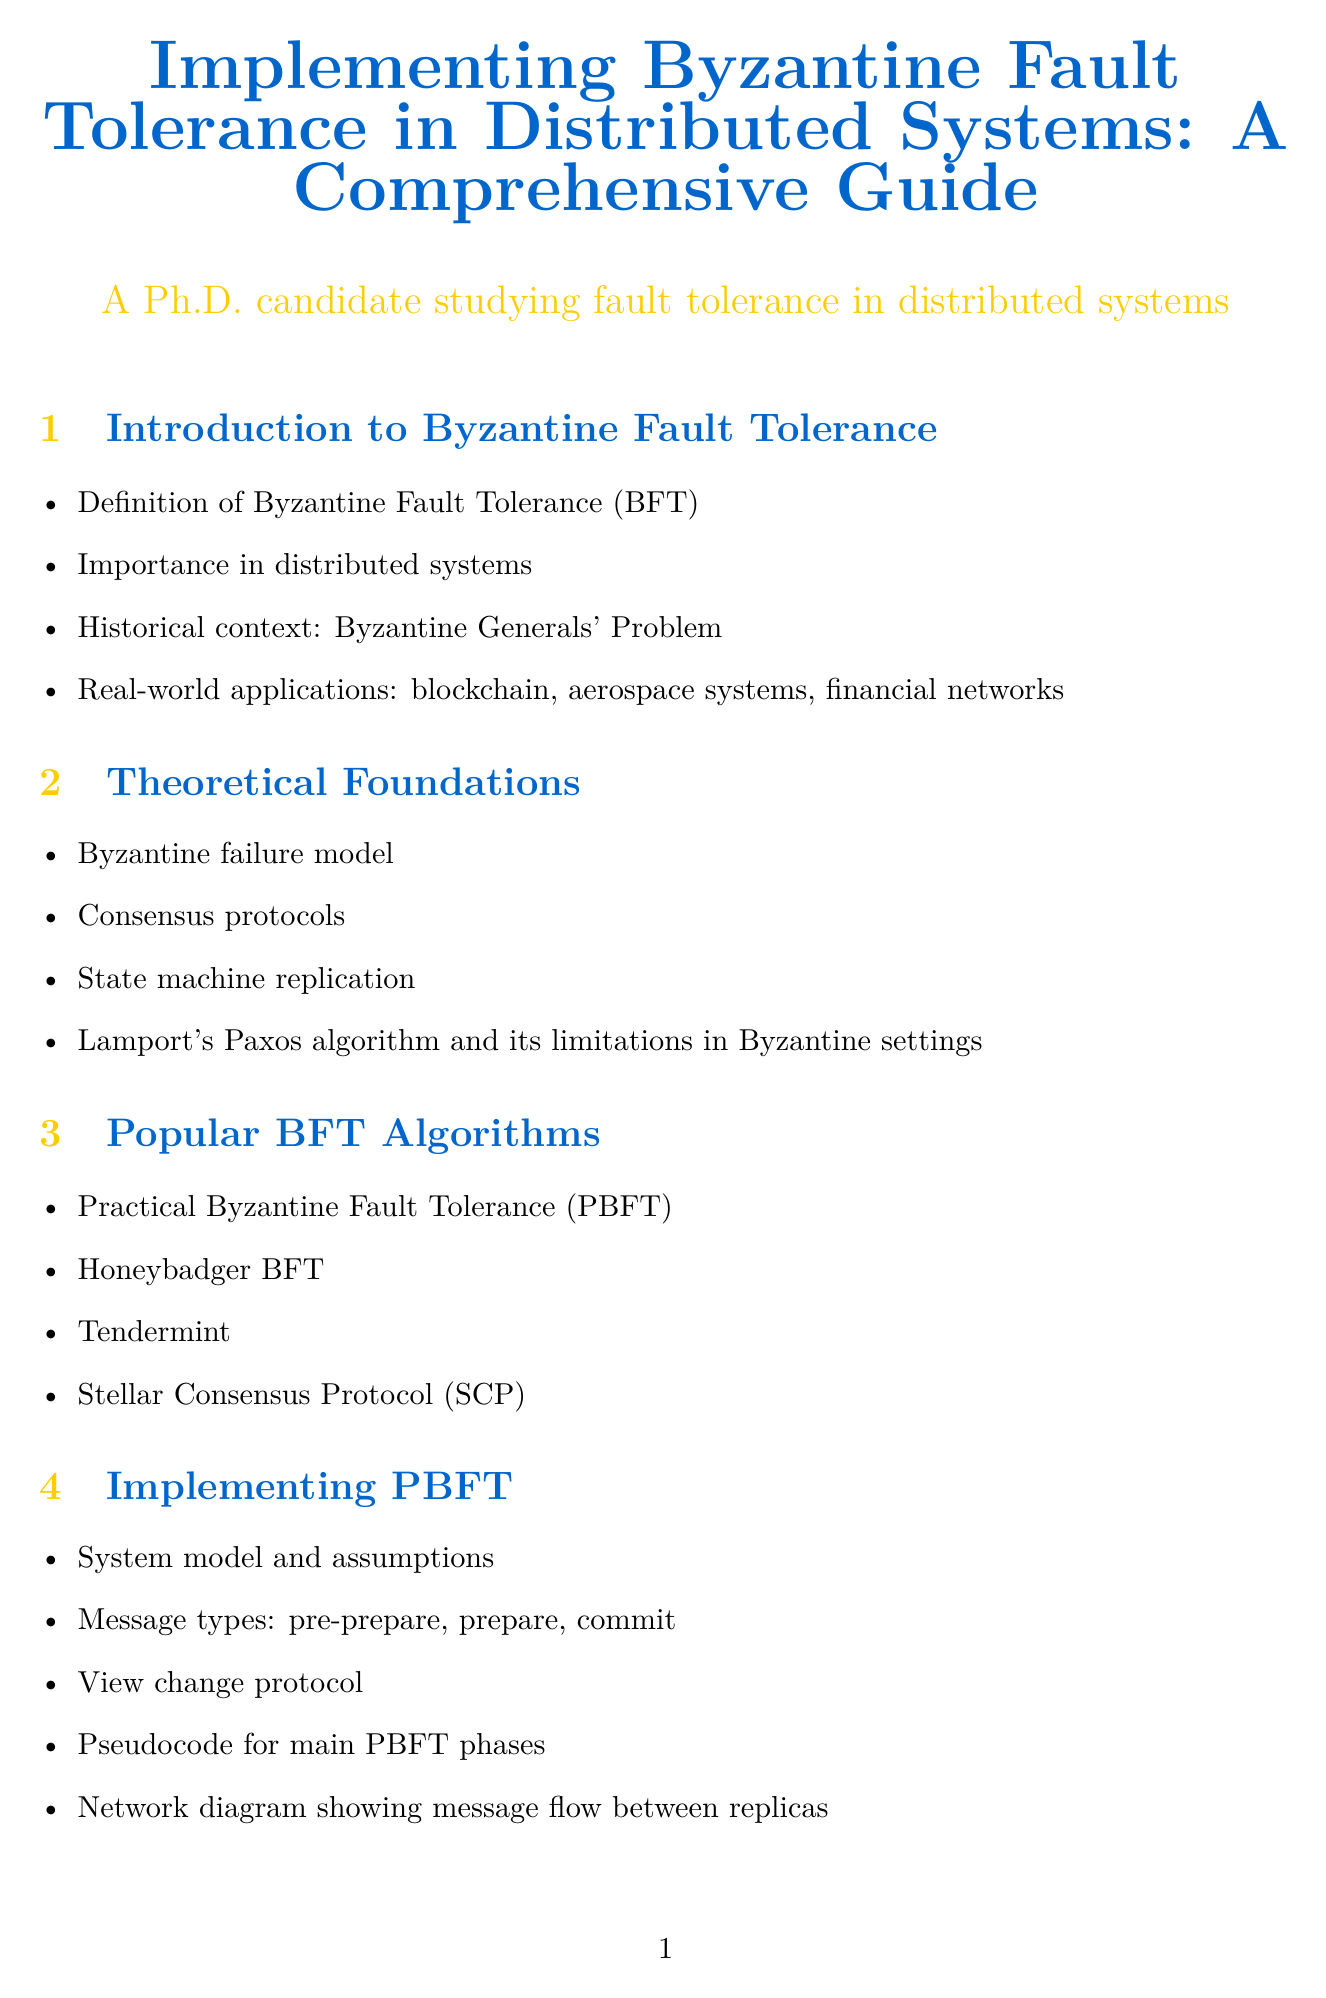What is the primary topic of the document? The title indicates that the document is about implementing Byzantine Fault Tolerance in distributed systems.
Answer: Implementing Byzantine Fault Tolerance in Distributed Systems What does BFT stand for? The document introduces the abbreviation BFT, which stands for Byzantine Fault Tolerance.
Answer: Byzantine Fault Tolerance What is the first algorithm discussed in the section on popular BFT algorithms? The first algorithm listed in the section is Practical Byzantine Fault Tolerance.
Answer: Practical Byzantine Fault Tolerance How many elements are shown in the PBFT Normal Case Operation diagram? The number of elements listed in the diagram description is seven, which include replicas, client, and message types.
Answer: seven What is a common attack vector mentioned in the security analysis section? The document lists DDoS as one of the common attack vectors within Byzantine Fault Tolerance systems.
Answer: DDoS What year was the work by Castro and Liskov published? The reference shows that the practical Byzantine Fault Tolerance paper was published in 1999.
Answer: 1999 Which programming language is used for PBFT primary replica message handling? The pseudocode provided for the primary replica handling is in Python.
Answer: Python What does the section on Performance Considerations discuss regarding network conditions? The section addresses the impact of network conditions on Byzantine Fault Tolerance protocols.
Answer: Impact of network conditions Which case study discusses BFT in NASA's operations? The case study section includes a discussion about BFT in NASA's Deep Space Network.
Answer: NASA's Deep Space Network 